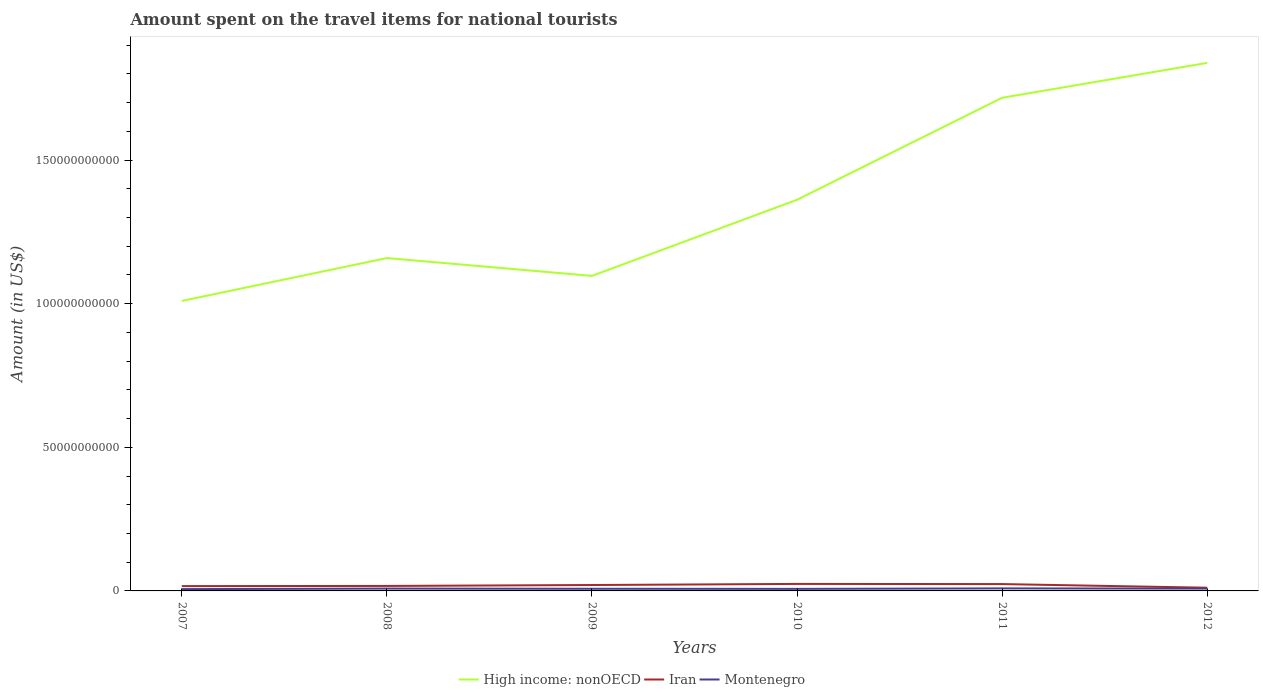Is the number of lines equal to the number of legend labels?
Offer a very short reply. Yes. Across all years, what is the maximum amount spent on the travel items for national tourists in Montenegro?
Your response must be concise. 6.30e+08. In which year was the amount spent on the travel items for national tourists in Montenegro maximum?
Provide a succinct answer. 2007. What is the total amount spent on the travel items for national tourists in High income: nonOECD in the graph?
Your answer should be very brief. -7.42e+1. What is the difference between the highest and the second highest amount spent on the travel items for national tourists in High income: nonOECD?
Give a very brief answer. 8.29e+1. What is the difference between the highest and the lowest amount spent on the travel items for national tourists in High income: nonOECD?
Your answer should be compact. 2. Is the amount spent on the travel items for national tourists in Iran strictly greater than the amount spent on the travel items for national tourists in High income: nonOECD over the years?
Your answer should be compact. Yes. How many years are there in the graph?
Offer a very short reply. 6. What is the difference between two consecutive major ticks on the Y-axis?
Provide a succinct answer. 5.00e+1. Are the values on the major ticks of Y-axis written in scientific E-notation?
Make the answer very short. No. Does the graph contain any zero values?
Offer a very short reply. No. Does the graph contain grids?
Ensure brevity in your answer.  No. Where does the legend appear in the graph?
Offer a very short reply. Bottom center. What is the title of the graph?
Ensure brevity in your answer.  Amount spent on the travel items for national tourists. Does "Portugal" appear as one of the legend labels in the graph?
Provide a short and direct response. No. What is the label or title of the X-axis?
Ensure brevity in your answer.  Years. What is the Amount (in US$) in High income: nonOECD in 2007?
Keep it short and to the point. 1.01e+11. What is the Amount (in US$) in Iran in 2007?
Give a very brief answer. 1.68e+09. What is the Amount (in US$) in Montenegro in 2007?
Offer a terse response. 6.30e+08. What is the Amount (in US$) in High income: nonOECD in 2008?
Ensure brevity in your answer.  1.16e+11. What is the Amount (in US$) in Iran in 2008?
Ensure brevity in your answer.  1.74e+09. What is the Amount (in US$) of Montenegro in 2008?
Offer a terse response. 8.13e+08. What is the Amount (in US$) in High income: nonOECD in 2009?
Keep it short and to the point. 1.10e+11. What is the Amount (in US$) of Iran in 2009?
Provide a succinct answer. 2.06e+09. What is the Amount (in US$) of Montenegro in 2009?
Provide a short and direct response. 7.45e+08. What is the Amount (in US$) of High income: nonOECD in 2010?
Provide a succinct answer. 1.36e+11. What is the Amount (in US$) in Iran in 2010?
Your response must be concise. 2.44e+09. What is the Amount (in US$) in Montenegro in 2010?
Offer a very short reply. 7.13e+08. What is the Amount (in US$) in High income: nonOECD in 2011?
Give a very brief answer. 1.72e+11. What is the Amount (in US$) in Iran in 2011?
Provide a succinct answer. 2.38e+09. What is the Amount (in US$) of Montenegro in 2011?
Ensure brevity in your answer.  8.75e+08. What is the Amount (in US$) of High income: nonOECD in 2012?
Give a very brief answer. 1.84e+11. What is the Amount (in US$) in Iran in 2012?
Ensure brevity in your answer.  1.11e+09. What is the Amount (in US$) of Montenegro in 2012?
Your answer should be very brief. 8.09e+08. Across all years, what is the maximum Amount (in US$) in High income: nonOECD?
Provide a short and direct response. 1.84e+11. Across all years, what is the maximum Amount (in US$) of Iran?
Ensure brevity in your answer.  2.44e+09. Across all years, what is the maximum Amount (in US$) in Montenegro?
Provide a short and direct response. 8.75e+08. Across all years, what is the minimum Amount (in US$) in High income: nonOECD?
Make the answer very short. 1.01e+11. Across all years, what is the minimum Amount (in US$) in Iran?
Ensure brevity in your answer.  1.11e+09. Across all years, what is the minimum Amount (in US$) of Montenegro?
Your answer should be very brief. 6.30e+08. What is the total Amount (in US$) of High income: nonOECD in the graph?
Ensure brevity in your answer.  8.18e+11. What is the total Amount (in US$) of Iran in the graph?
Give a very brief answer. 1.14e+1. What is the total Amount (in US$) of Montenegro in the graph?
Your answer should be compact. 4.58e+09. What is the difference between the Amount (in US$) in High income: nonOECD in 2007 and that in 2008?
Make the answer very short. -1.49e+1. What is the difference between the Amount (in US$) in Iran in 2007 and that in 2008?
Your answer should be compact. -6.00e+07. What is the difference between the Amount (in US$) of Montenegro in 2007 and that in 2008?
Provide a short and direct response. -1.83e+08. What is the difference between the Amount (in US$) of High income: nonOECD in 2007 and that in 2009?
Provide a short and direct response. -8.72e+09. What is the difference between the Amount (in US$) in Iran in 2007 and that in 2009?
Your response must be concise. -3.78e+08. What is the difference between the Amount (in US$) in Montenegro in 2007 and that in 2009?
Provide a short and direct response. -1.15e+08. What is the difference between the Amount (in US$) in High income: nonOECD in 2007 and that in 2010?
Keep it short and to the point. -3.52e+1. What is the difference between the Amount (in US$) of Iran in 2007 and that in 2010?
Give a very brief answer. -7.61e+08. What is the difference between the Amount (in US$) in Montenegro in 2007 and that in 2010?
Your answer should be compact. -8.30e+07. What is the difference between the Amount (in US$) in High income: nonOECD in 2007 and that in 2011?
Offer a terse response. -7.07e+1. What is the difference between the Amount (in US$) of Iran in 2007 and that in 2011?
Provide a succinct answer. -7.04e+08. What is the difference between the Amount (in US$) of Montenegro in 2007 and that in 2011?
Your answer should be compact. -2.45e+08. What is the difference between the Amount (in US$) in High income: nonOECD in 2007 and that in 2012?
Give a very brief answer. -8.29e+1. What is the difference between the Amount (in US$) in Iran in 2007 and that in 2012?
Keep it short and to the point. 5.63e+08. What is the difference between the Amount (in US$) in Montenegro in 2007 and that in 2012?
Provide a succinct answer. -1.79e+08. What is the difference between the Amount (in US$) in High income: nonOECD in 2008 and that in 2009?
Keep it short and to the point. 6.21e+09. What is the difference between the Amount (in US$) of Iran in 2008 and that in 2009?
Make the answer very short. -3.18e+08. What is the difference between the Amount (in US$) of Montenegro in 2008 and that in 2009?
Your response must be concise. 6.80e+07. What is the difference between the Amount (in US$) of High income: nonOECD in 2008 and that in 2010?
Give a very brief answer. -2.03e+1. What is the difference between the Amount (in US$) in Iran in 2008 and that in 2010?
Provide a succinct answer. -7.01e+08. What is the difference between the Amount (in US$) in High income: nonOECD in 2008 and that in 2011?
Your answer should be compact. -5.58e+1. What is the difference between the Amount (in US$) in Iran in 2008 and that in 2011?
Your answer should be very brief. -6.44e+08. What is the difference between the Amount (in US$) of Montenegro in 2008 and that in 2011?
Your answer should be very brief. -6.20e+07. What is the difference between the Amount (in US$) of High income: nonOECD in 2008 and that in 2012?
Keep it short and to the point. -6.79e+1. What is the difference between the Amount (in US$) of Iran in 2008 and that in 2012?
Provide a succinct answer. 6.23e+08. What is the difference between the Amount (in US$) of High income: nonOECD in 2009 and that in 2010?
Your answer should be compact. -2.65e+1. What is the difference between the Amount (in US$) of Iran in 2009 and that in 2010?
Your answer should be very brief. -3.83e+08. What is the difference between the Amount (in US$) in Montenegro in 2009 and that in 2010?
Your answer should be very brief. 3.20e+07. What is the difference between the Amount (in US$) in High income: nonOECD in 2009 and that in 2011?
Your answer should be very brief. -6.20e+1. What is the difference between the Amount (in US$) in Iran in 2009 and that in 2011?
Your response must be concise. -3.26e+08. What is the difference between the Amount (in US$) of Montenegro in 2009 and that in 2011?
Offer a terse response. -1.30e+08. What is the difference between the Amount (in US$) in High income: nonOECD in 2009 and that in 2012?
Provide a succinct answer. -7.42e+1. What is the difference between the Amount (in US$) of Iran in 2009 and that in 2012?
Your answer should be very brief. 9.41e+08. What is the difference between the Amount (in US$) of Montenegro in 2009 and that in 2012?
Make the answer very short. -6.40e+07. What is the difference between the Amount (in US$) in High income: nonOECD in 2010 and that in 2011?
Your response must be concise. -3.55e+1. What is the difference between the Amount (in US$) of Iran in 2010 and that in 2011?
Your answer should be compact. 5.70e+07. What is the difference between the Amount (in US$) of Montenegro in 2010 and that in 2011?
Make the answer very short. -1.62e+08. What is the difference between the Amount (in US$) in High income: nonOECD in 2010 and that in 2012?
Your response must be concise. -4.76e+1. What is the difference between the Amount (in US$) in Iran in 2010 and that in 2012?
Provide a succinct answer. 1.32e+09. What is the difference between the Amount (in US$) in Montenegro in 2010 and that in 2012?
Make the answer very short. -9.60e+07. What is the difference between the Amount (in US$) of High income: nonOECD in 2011 and that in 2012?
Your answer should be compact. -1.21e+1. What is the difference between the Amount (in US$) in Iran in 2011 and that in 2012?
Provide a short and direct response. 1.27e+09. What is the difference between the Amount (in US$) of Montenegro in 2011 and that in 2012?
Offer a terse response. 6.60e+07. What is the difference between the Amount (in US$) in High income: nonOECD in 2007 and the Amount (in US$) in Iran in 2008?
Offer a very short reply. 9.92e+1. What is the difference between the Amount (in US$) of High income: nonOECD in 2007 and the Amount (in US$) of Montenegro in 2008?
Provide a short and direct response. 1.00e+11. What is the difference between the Amount (in US$) in Iran in 2007 and the Amount (in US$) in Montenegro in 2008?
Offer a very short reply. 8.64e+08. What is the difference between the Amount (in US$) in High income: nonOECD in 2007 and the Amount (in US$) in Iran in 2009?
Your answer should be compact. 9.89e+1. What is the difference between the Amount (in US$) of High income: nonOECD in 2007 and the Amount (in US$) of Montenegro in 2009?
Give a very brief answer. 1.00e+11. What is the difference between the Amount (in US$) of Iran in 2007 and the Amount (in US$) of Montenegro in 2009?
Ensure brevity in your answer.  9.32e+08. What is the difference between the Amount (in US$) in High income: nonOECD in 2007 and the Amount (in US$) in Iran in 2010?
Your answer should be very brief. 9.85e+1. What is the difference between the Amount (in US$) of High income: nonOECD in 2007 and the Amount (in US$) of Montenegro in 2010?
Your answer should be very brief. 1.00e+11. What is the difference between the Amount (in US$) in Iran in 2007 and the Amount (in US$) in Montenegro in 2010?
Keep it short and to the point. 9.64e+08. What is the difference between the Amount (in US$) of High income: nonOECD in 2007 and the Amount (in US$) of Iran in 2011?
Your response must be concise. 9.86e+1. What is the difference between the Amount (in US$) of High income: nonOECD in 2007 and the Amount (in US$) of Montenegro in 2011?
Give a very brief answer. 1.00e+11. What is the difference between the Amount (in US$) in Iran in 2007 and the Amount (in US$) in Montenegro in 2011?
Your answer should be compact. 8.02e+08. What is the difference between the Amount (in US$) of High income: nonOECD in 2007 and the Amount (in US$) of Iran in 2012?
Ensure brevity in your answer.  9.98e+1. What is the difference between the Amount (in US$) in High income: nonOECD in 2007 and the Amount (in US$) in Montenegro in 2012?
Keep it short and to the point. 1.00e+11. What is the difference between the Amount (in US$) in Iran in 2007 and the Amount (in US$) in Montenegro in 2012?
Offer a very short reply. 8.68e+08. What is the difference between the Amount (in US$) of High income: nonOECD in 2008 and the Amount (in US$) of Iran in 2009?
Provide a short and direct response. 1.14e+11. What is the difference between the Amount (in US$) of High income: nonOECD in 2008 and the Amount (in US$) of Montenegro in 2009?
Make the answer very short. 1.15e+11. What is the difference between the Amount (in US$) of Iran in 2008 and the Amount (in US$) of Montenegro in 2009?
Your answer should be compact. 9.92e+08. What is the difference between the Amount (in US$) in High income: nonOECD in 2008 and the Amount (in US$) in Iran in 2010?
Keep it short and to the point. 1.13e+11. What is the difference between the Amount (in US$) in High income: nonOECD in 2008 and the Amount (in US$) in Montenegro in 2010?
Offer a very short reply. 1.15e+11. What is the difference between the Amount (in US$) of Iran in 2008 and the Amount (in US$) of Montenegro in 2010?
Give a very brief answer. 1.02e+09. What is the difference between the Amount (in US$) in High income: nonOECD in 2008 and the Amount (in US$) in Iran in 2011?
Make the answer very short. 1.13e+11. What is the difference between the Amount (in US$) of High income: nonOECD in 2008 and the Amount (in US$) of Montenegro in 2011?
Offer a very short reply. 1.15e+11. What is the difference between the Amount (in US$) of Iran in 2008 and the Amount (in US$) of Montenegro in 2011?
Your answer should be compact. 8.62e+08. What is the difference between the Amount (in US$) in High income: nonOECD in 2008 and the Amount (in US$) in Iran in 2012?
Provide a succinct answer. 1.15e+11. What is the difference between the Amount (in US$) in High income: nonOECD in 2008 and the Amount (in US$) in Montenegro in 2012?
Make the answer very short. 1.15e+11. What is the difference between the Amount (in US$) of Iran in 2008 and the Amount (in US$) of Montenegro in 2012?
Ensure brevity in your answer.  9.28e+08. What is the difference between the Amount (in US$) of High income: nonOECD in 2009 and the Amount (in US$) of Iran in 2010?
Your answer should be compact. 1.07e+11. What is the difference between the Amount (in US$) in High income: nonOECD in 2009 and the Amount (in US$) in Montenegro in 2010?
Provide a short and direct response. 1.09e+11. What is the difference between the Amount (in US$) of Iran in 2009 and the Amount (in US$) of Montenegro in 2010?
Your answer should be compact. 1.34e+09. What is the difference between the Amount (in US$) in High income: nonOECD in 2009 and the Amount (in US$) in Iran in 2011?
Ensure brevity in your answer.  1.07e+11. What is the difference between the Amount (in US$) in High income: nonOECD in 2009 and the Amount (in US$) in Montenegro in 2011?
Offer a terse response. 1.09e+11. What is the difference between the Amount (in US$) in Iran in 2009 and the Amount (in US$) in Montenegro in 2011?
Ensure brevity in your answer.  1.18e+09. What is the difference between the Amount (in US$) in High income: nonOECD in 2009 and the Amount (in US$) in Iran in 2012?
Offer a terse response. 1.09e+11. What is the difference between the Amount (in US$) of High income: nonOECD in 2009 and the Amount (in US$) of Montenegro in 2012?
Your response must be concise. 1.09e+11. What is the difference between the Amount (in US$) in Iran in 2009 and the Amount (in US$) in Montenegro in 2012?
Offer a very short reply. 1.25e+09. What is the difference between the Amount (in US$) in High income: nonOECD in 2010 and the Amount (in US$) in Iran in 2011?
Keep it short and to the point. 1.34e+11. What is the difference between the Amount (in US$) of High income: nonOECD in 2010 and the Amount (in US$) of Montenegro in 2011?
Your response must be concise. 1.35e+11. What is the difference between the Amount (in US$) of Iran in 2010 and the Amount (in US$) of Montenegro in 2011?
Provide a short and direct response. 1.56e+09. What is the difference between the Amount (in US$) of High income: nonOECD in 2010 and the Amount (in US$) of Iran in 2012?
Provide a succinct answer. 1.35e+11. What is the difference between the Amount (in US$) in High income: nonOECD in 2010 and the Amount (in US$) in Montenegro in 2012?
Your answer should be very brief. 1.35e+11. What is the difference between the Amount (in US$) in Iran in 2010 and the Amount (in US$) in Montenegro in 2012?
Your answer should be very brief. 1.63e+09. What is the difference between the Amount (in US$) of High income: nonOECD in 2011 and the Amount (in US$) of Iran in 2012?
Offer a terse response. 1.71e+11. What is the difference between the Amount (in US$) in High income: nonOECD in 2011 and the Amount (in US$) in Montenegro in 2012?
Offer a very short reply. 1.71e+11. What is the difference between the Amount (in US$) of Iran in 2011 and the Amount (in US$) of Montenegro in 2012?
Offer a very short reply. 1.57e+09. What is the average Amount (in US$) of High income: nonOECD per year?
Your answer should be compact. 1.36e+11. What is the average Amount (in US$) of Iran per year?
Offer a terse response. 1.90e+09. What is the average Amount (in US$) of Montenegro per year?
Your response must be concise. 7.64e+08. In the year 2007, what is the difference between the Amount (in US$) in High income: nonOECD and Amount (in US$) in Iran?
Give a very brief answer. 9.93e+1. In the year 2007, what is the difference between the Amount (in US$) in High income: nonOECD and Amount (in US$) in Montenegro?
Give a very brief answer. 1.00e+11. In the year 2007, what is the difference between the Amount (in US$) in Iran and Amount (in US$) in Montenegro?
Provide a short and direct response. 1.05e+09. In the year 2008, what is the difference between the Amount (in US$) in High income: nonOECD and Amount (in US$) in Iran?
Keep it short and to the point. 1.14e+11. In the year 2008, what is the difference between the Amount (in US$) of High income: nonOECD and Amount (in US$) of Montenegro?
Your answer should be very brief. 1.15e+11. In the year 2008, what is the difference between the Amount (in US$) of Iran and Amount (in US$) of Montenegro?
Your response must be concise. 9.24e+08. In the year 2009, what is the difference between the Amount (in US$) of High income: nonOECD and Amount (in US$) of Iran?
Provide a succinct answer. 1.08e+11. In the year 2009, what is the difference between the Amount (in US$) of High income: nonOECD and Amount (in US$) of Montenegro?
Your answer should be compact. 1.09e+11. In the year 2009, what is the difference between the Amount (in US$) of Iran and Amount (in US$) of Montenegro?
Offer a terse response. 1.31e+09. In the year 2010, what is the difference between the Amount (in US$) in High income: nonOECD and Amount (in US$) in Iran?
Keep it short and to the point. 1.34e+11. In the year 2010, what is the difference between the Amount (in US$) in High income: nonOECD and Amount (in US$) in Montenegro?
Offer a very short reply. 1.35e+11. In the year 2010, what is the difference between the Amount (in US$) of Iran and Amount (in US$) of Montenegro?
Offer a very short reply. 1.72e+09. In the year 2011, what is the difference between the Amount (in US$) in High income: nonOECD and Amount (in US$) in Iran?
Keep it short and to the point. 1.69e+11. In the year 2011, what is the difference between the Amount (in US$) of High income: nonOECD and Amount (in US$) of Montenegro?
Your answer should be very brief. 1.71e+11. In the year 2011, what is the difference between the Amount (in US$) in Iran and Amount (in US$) in Montenegro?
Your answer should be very brief. 1.51e+09. In the year 2012, what is the difference between the Amount (in US$) of High income: nonOECD and Amount (in US$) of Iran?
Offer a terse response. 1.83e+11. In the year 2012, what is the difference between the Amount (in US$) in High income: nonOECD and Amount (in US$) in Montenegro?
Make the answer very short. 1.83e+11. In the year 2012, what is the difference between the Amount (in US$) in Iran and Amount (in US$) in Montenegro?
Your answer should be compact. 3.05e+08. What is the ratio of the Amount (in US$) of High income: nonOECD in 2007 to that in 2008?
Offer a very short reply. 0.87. What is the ratio of the Amount (in US$) of Iran in 2007 to that in 2008?
Offer a very short reply. 0.97. What is the ratio of the Amount (in US$) in Montenegro in 2007 to that in 2008?
Your answer should be very brief. 0.77. What is the ratio of the Amount (in US$) of High income: nonOECD in 2007 to that in 2009?
Your answer should be very brief. 0.92. What is the ratio of the Amount (in US$) in Iran in 2007 to that in 2009?
Give a very brief answer. 0.82. What is the ratio of the Amount (in US$) in Montenegro in 2007 to that in 2009?
Offer a terse response. 0.85. What is the ratio of the Amount (in US$) of High income: nonOECD in 2007 to that in 2010?
Your response must be concise. 0.74. What is the ratio of the Amount (in US$) of Iran in 2007 to that in 2010?
Make the answer very short. 0.69. What is the ratio of the Amount (in US$) in Montenegro in 2007 to that in 2010?
Ensure brevity in your answer.  0.88. What is the ratio of the Amount (in US$) of High income: nonOECD in 2007 to that in 2011?
Make the answer very short. 0.59. What is the ratio of the Amount (in US$) in Iran in 2007 to that in 2011?
Your response must be concise. 0.7. What is the ratio of the Amount (in US$) of Montenegro in 2007 to that in 2011?
Give a very brief answer. 0.72. What is the ratio of the Amount (in US$) in High income: nonOECD in 2007 to that in 2012?
Give a very brief answer. 0.55. What is the ratio of the Amount (in US$) in Iran in 2007 to that in 2012?
Your answer should be very brief. 1.51. What is the ratio of the Amount (in US$) in Montenegro in 2007 to that in 2012?
Ensure brevity in your answer.  0.78. What is the ratio of the Amount (in US$) in High income: nonOECD in 2008 to that in 2009?
Offer a terse response. 1.06. What is the ratio of the Amount (in US$) of Iran in 2008 to that in 2009?
Make the answer very short. 0.85. What is the ratio of the Amount (in US$) of Montenegro in 2008 to that in 2009?
Your response must be concise. 1.09. What is the ratio of the Amount (in US$) in High income: nonOECD in 2008 to that in 2010?
Provide a short and direct response. 0.85. What is the ratio of the Amount (in US$) of Iran in 2008 to that in 2010?
Provide a succinct answer. 0.71. What is the ratio of the Amount (in US$) of Montenegro in 2008 to that in 2010?
Keep it short and to the point. 1.14. What is the ratio of the Amount (in US$) of High income: nonOECD in 2008 to that in 2011?
Your response must be concise. 0.68. What is the ratio of the Amount (in US$) of Iran in 2008 to that in 2011?
Offer a very short reply. 0.73. What is the ratio of the Amount (in US$) in Montenegro in 2008 to that in 2011?
Make the answer very short. 0.93. What is the ratio of the Amount (in US$) of High income: nonOECD in 2008 to that in 2012?
Ensure brevity in your answer.  0.63. What is the ratio of the Amount (in US$) in Iran in 2008 to that in 2012?
Your answer should be compact. 1.56. What is the ratio of the Amount (in US$) of High income: nonOECD in 2009 to that in 2010?
Offer a terse response. 0.81. What is the ratio of the Amount (in US$) in Iran in 2009 to that in 2010?
Your answer should be very brief. 0.84. What is the ratio of the Amount (in US$) in Montenegro in 2009 to that in 2010?
Offer a terse response. 1.04. What is the ratio of the Amount (in US$) in High income: nonOECD in 2009 to that in 2011?
Give a very brief answer. 0.64. What is the ratio of the Amount (in US$) of Iran in 2009 to that in 2011?
Your response must be concise. 0.86. What is the ratio of the Amount (in US$) of Montenegro in 2009 to that in 2011?
Your response must be concise. 0.85. What is the ratio of the Amount (in US$) of High income: nonOECD in 2009 to that in 2012?
Give a very brief answer. 0.6. What is the ratio of the Amount (in US$) in Iran in 2009 to that in 2012?
Keep it short and to the point. 1.84. What is the ratio of the Amount (in US$) in Montenegro in 2009 to that in 2012?
Make the answer very short. 0.92. What is the ratio of the Amount (in US$) in High income: nonOECD in 2010 to that in 2011?
Offer a very short reply. 0.79. What is the ratio of the Amount (in US$) of Iran in 2010 to that in 2011?
Your answer should be very brief. 1.02. What is the ratio of the Amount (in US$) of Montenegro in 2010 to that in 2011?
Give a very brief answer. 0.81. What is the ratio of the Amount (in US$) in High income: nonOECD in 2010 to that in 2012?
Keep it short and to the point. 0.74. What is the ratio of the Amount (in US$) of Iran in 2010 to that in 2012?
Your response must be concise. 2.19. What is the ratio of the Amount (in US$) in Montenegro in 2010 to that in 2012?
Your answer should be very brief. 0.88. What is the ratio of the Amount (in US$) of High income: nonOECD in 2011 to that in 2012?
Offer a very short reply. 0.93. What is the ratio of the Amount (in US$) of Iran in 2011 to that in 2012?
Your answer should be very brief. 2.14. What is the ratio of the Amount (in US$) of Montenegro in 2011 to that in 2012?
Provide a succinct answer. 1.08. What is the difference between the highest and the second highest Amount (in US$) in High income: nonOECD?
Provide a succinct answer. 1.21e+1. What is the difference between the highest and the second highest Amount (in US$) of Iran?
Provide a succinct answer. 5.70e+07. What is the difference between the highest and the second highest Amount (in US$) in Montenegro?
Offer a terse response. 6.20e+07. What is the difference between the highest and the lowest Amount (in US$) of High income: nonOECD?
Your answer should be very brief. 8.29e+1. What is the difference between the highest and the lowest Amount (in US$) of Iran?
Your response must be concise. 1.32e+09. What is the difference between the highest and the lowest Amount (in US$) of Montenegro?
Make the answer very short. 2.45e+08. 